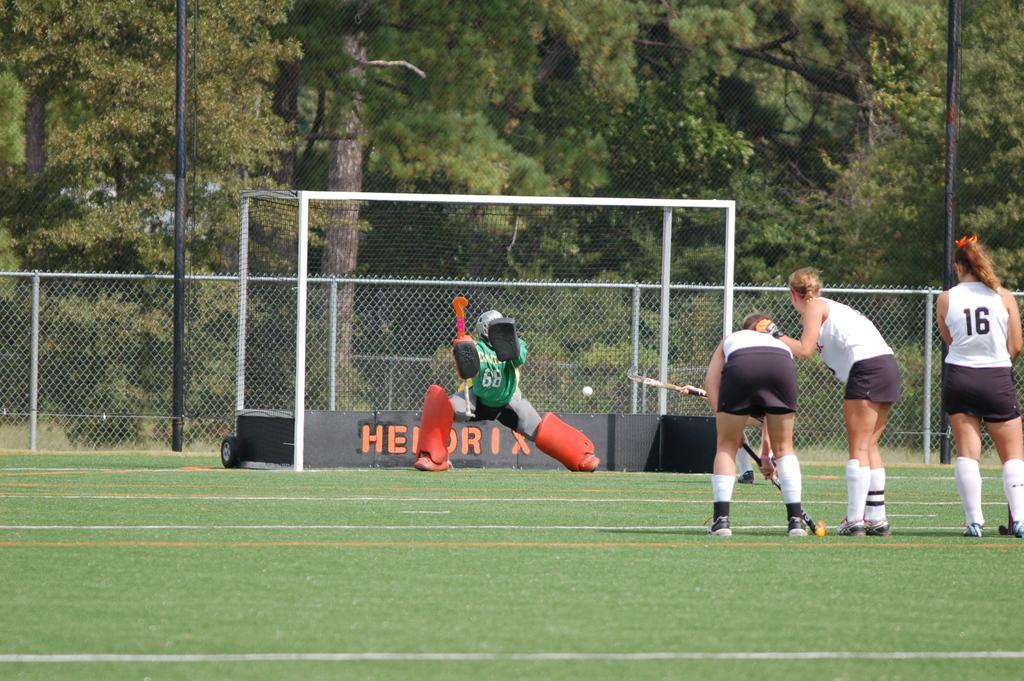<image>
Share a concise interpretation of the image provided. A field hockey player is wearing number 16 on her shirt. 